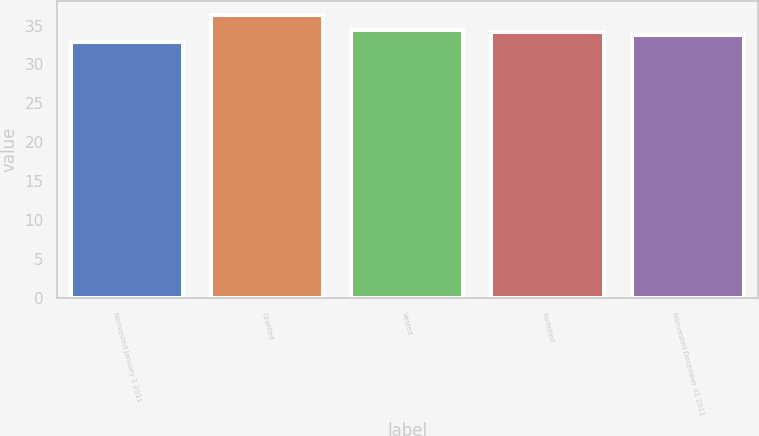Convert chart. <chart><loc_0><loc_0><loc_500><loc_500><bar_chart><fcel>Nonvested January 1 2011<fcel>Granted<fcel>Vested<fcel>Forfeited<fcel>Nonvested December 31 2011<nl><fcel>32.88<fcel>36.36<fcel>34.46<fcel>34.11<fcel>33.73<nl></chart> 